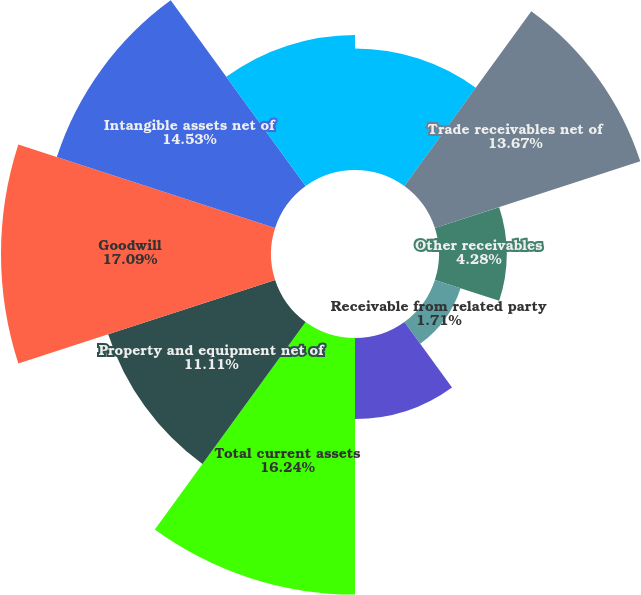<chart> <loc_0><loc_0><loc_500><loc_500><pie_chart><fcel>Cash and cash equivalents<fcel>Trade receivables net of<fcel>Other receivables<fcel>Receivable from related party<fcel>Prepaid expenses and other<fcel>Total current assets<fcel>Property and equipment net of<fcel>Goodwill<fcel>Intangible assets net of<fcel>Investment in unconsolidated<nl><fcel>7.69%<fcel>13.67%<fcel>4.28%<fcel>1.71%<fcel>5.13%<fcel>16.24%<fcel>11.11%<fcel>17.09%<fcel>14.53%<fcel>8.55%<nl></chart> 